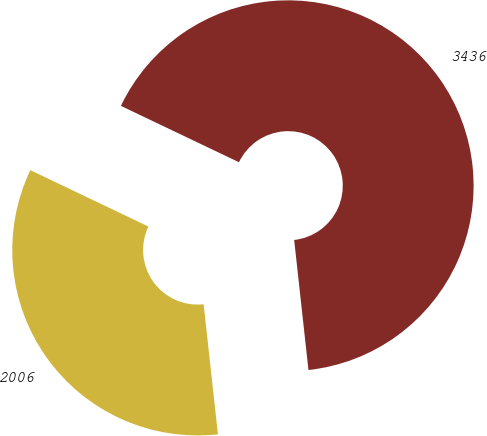Convert chart. <chart><loc_0><loc_0><loc_500><loc_500><pie_chart><fcel>2006<fcel>3436<nl><fcel>33.83%<fcel>66.17%<nl></chart> 